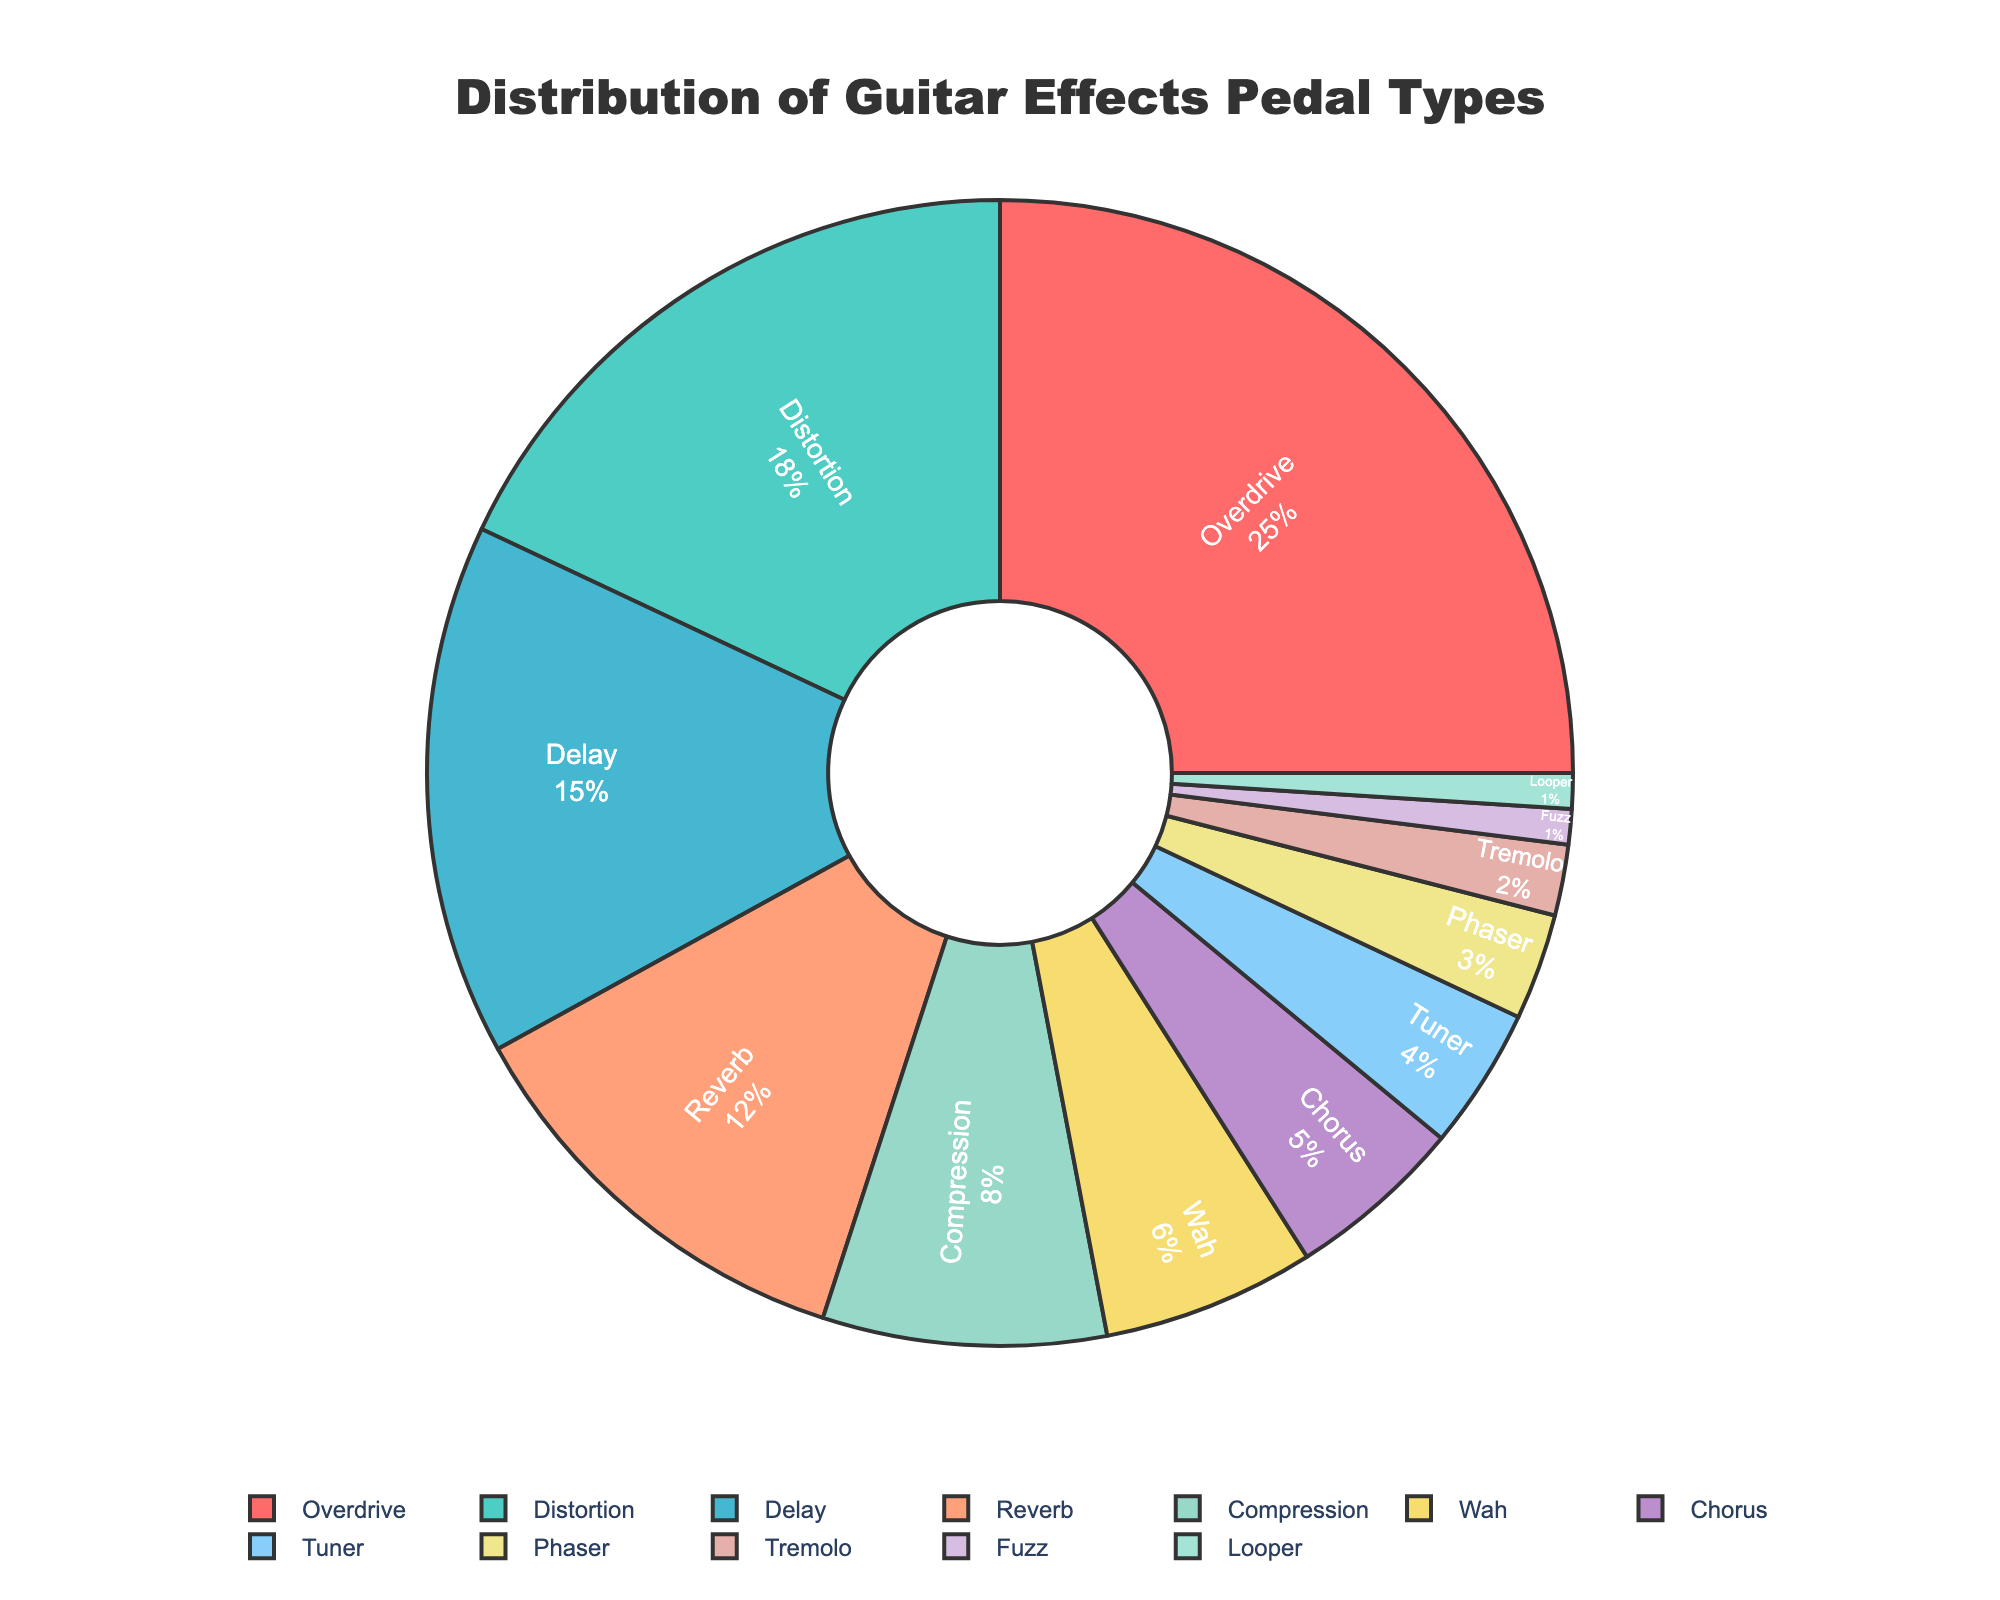What percentage of guitar effects pedals used are either Overdrive or Distortion? Overdrive is 25% and Distortion is 18%. To find the total, add these percentages: 25% + 18% = 43%.
Answer: 43% Which effect type is used more, Delay or Reverb? Delay has a percentage of 15%, while Reverb is at 12%. Comparing these values, Delay is used more.
Answer: Delay How much more common are Overdrive pedals compared to Chorus pedals? Overdrive pedals are used 25% and Chorus pedals are used 5%. The difference is 25% - 5% = 20%.
Answer: 20% Rank the top three most commonly used effect types. The percentages for each type are: Overdrive (25%), Distortion (18%), and Delay (15%). Therefore, the top three are Overdrive, Distortion, and Delay.
Answer: Overdrive, Distortion, Delay What is the total percentage of all modulation effects (Wah, Chorus, Phaser, Tremolo)? Wah is 6%, Chorus is 5%, Phaser is 3%, and Tremolo is 2%. Adding these gives a total: 6% + 5% + 3% + 2% = 16%.
Answer: 16% Which effect type has the smallest usage and what is its percentage? Both Fuzz and Looper pedals have the smallest usage at 1%.
Answer: Fuzz and Looper, 1% Are Tuner pedals used more frequently than Compression pedals? Tuner pedals have a usage of 4%, while Compression pedals have an 8% usage. Hence, Tuner is used less frequently than Compression.
Answer: No What is the combined percentage of Delay and Reverb pedals? Delay pedals are used 15%, and Reverb pedals are 12%. Their combined percentage is: 15% + 12% = 27%.
Answer: 27% If the total number of effects pedals reviewed is 1000, how many of these are Phaser pedals? Phaser pedals account for 3%. If the total number of pedals is 1000, then the number of Phaser pedals is 1000 * 0.03 = 30.
Answer: 30 Is the usage of Overdrive pedals more than double that of Delay pedals? Overdrive pedals are 25%, and Delay pedals are 15%. Double of Delay is 2 * 15% = 30%. Since 25% is less than 30%, the usage of Overdrive is not more than double that of Delay.
Answer: No 